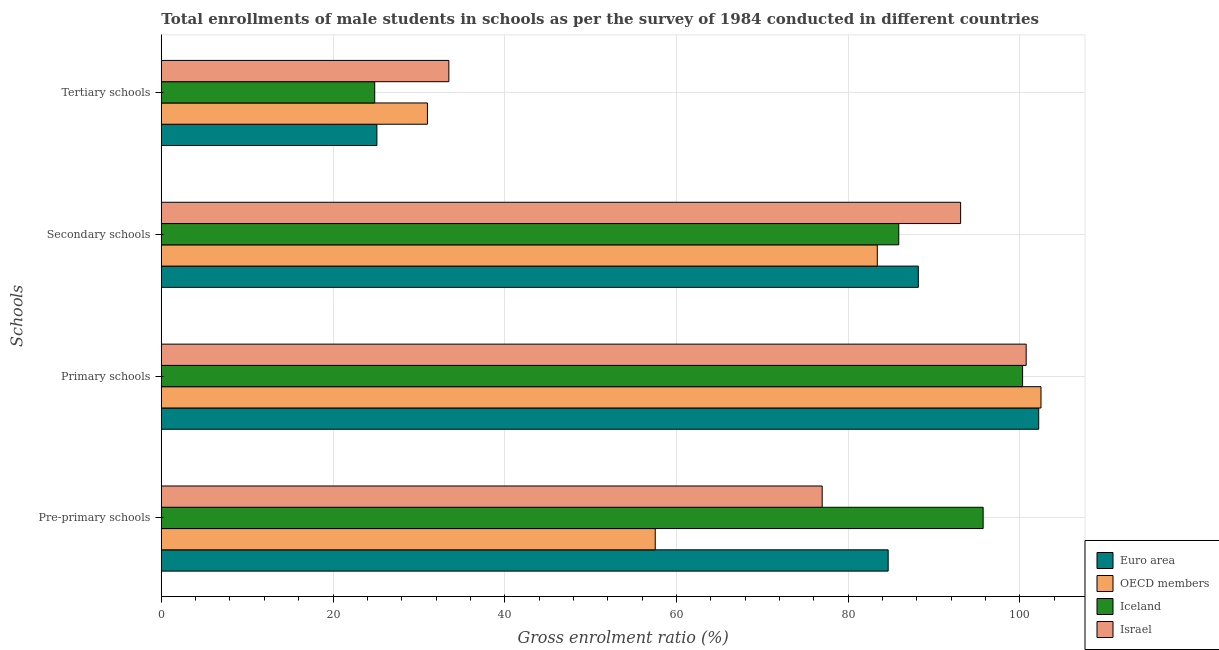How many bars are there on the 2nd tick from the top?
Provide a succinct answer. 4. How many bars are there on the 2nd tick from the bottom?
Ensure brevity in your answer.  4. What is the label of the 2nd group of bars from the top?
Give a very brief answer. Secondary schools. What is the gross enrolment ratio(male) in tertiary schools in Israel?
Ensure brevity in your answer.  33.5. Across all countries, what is the maximum gross enrolment ratio(male) in primary schools?
Your response must be concise. 102.48. Across all countries, what is the minimum gross enrolment ratio(male) in tertiary schools?
Offer a terse response. 24.86. In which country was the gross enrolment ratio(male) in primary schools maximum?
Provide a succinct answer. OECD members. In which country was the gross enrolment ratio(male) in pre-primary schools minimum?
Your answer should be very brief. OECD members. What is the total gross enrolment ratio(male) in tertiary schools in the graph?
Ensure brevity in your answer.  114.47. What is the difference between the gross enrolment ratio(male) in tertiary schools in Israel and that in Euro area?
Provide a short and direct response. 8.38. What is the difference between the gross enrolment ratio(male) in tertiary schools in OECD members and the gross enrolment ratio(male) in pre-primary schools in Israel?
Make the answer very short. -45.99. What is the average gross enrolment ratio(male) in pre-primary schools per country?
Give a very brief answer. 78.74. What is the difference between the gross enrolment ratio(male) in pre-primary schools and gross enrolment ratio(male) in tertiary schools in Euro area?
Give a very brief answer. 59.56. What is the ratio of the gross enrolment ratio(male) in secondary schools in Iceland to that in Israel?
Your answer should be compact. 0.92. Is the gross enrolment ratio(male) in tertiary schools in Euro area less than that in Iceland?
Provide a short and direct response. No. Is the difference between the gross enrolment ratio(male) in pre-primary schools in Iceland and Israel greater than the difference between the gross enrolment ratio(male) in tertiary schools in Iceland and Israel?
Your answer should be very brief. Yes. What is the difference between the highest and the second highest gross enrolment ratio(male) in primary schools?
Provide a short and direct response. 0.27. What is the difference between the highest and the lowest gross enrolment ratio(male) in tertiary schools?
Your answer should be very brief. 8.64. In how many countries, is the gross enrolment ratio(male) in tertiary schools greater than the average gross enrolment ratio(male) in tertiary schools taken over all countries?
Make the answer very short. 2. Is the sum of the gross enrolment ratio(male) in pre-primary schools in Israel and OECD members greater than the maximum gross enrolment ratio(male) in secondary schools across all countries?
Provide a short and direct response. Yes. What does the 2nd bar from the top in Primary schools represents?
Your answer should be very brief. Iceland. Is it the case that in every country, the sum of the gross enrolment ratio(male) in pre-primary schools and gross enrolment ratio(male) in primary schools is greater than the gross enrolment ratio(male) in secondary schools?
Your answer should be very brief. Yes. What is the difference between two consecutive major ticks on the X-axis?
Your response must be concise. 20. Are the values on the major ticks of X-axis written in scientific E-notation?
Offer a terse response. No. Does the graph contain any zero values?
Your answer should be compact. No. How many legend labels are there?
Make the answer very short. 4. What is the title of the graph?
Offer a terse response. Total enrollments of male students in schools as per the survey of 1984 conducted in different countries. What is the label or title of the Y-axis?
Offer a very short reply. Schools. What is the Gross enrolment ratio (%) of Euro area in Pre-primary schools?
Give a very brief answer. 84.68. What is the Gross enrolment ratio (%) of OECD members in Pre-primary schools?
Provide a short and direct response. 57.54. What is the Gross enrolment ratio (%) of Iceland in Pre-primary schools?
Ensure brevity in your answer.  95.74. What is the Gross enrolment ratio (%) of Israel in Pre-primary schools?
Offer a very short reply. 76.99. What is the Gross enrolment ratio (%) of Euro area in Primary schools?
Give a very brief answer. 102.21. What is the Gross enrolment ratio (%) of OECD members in Primary schools?
Offer a terse response. 102.48. What is the Gross enrolment ratio (%) of Iceland in Primary schools?
Your answer should be compact. 100.33. What is the Gross enrolment ratio (%) in Israel in Primary schools?
Provide a short and direct response. 100.75. What is the Gross enrolment ratio (%) in Euro area in Secondary schools?
Make the answer very short. 88.19. What is the Gross enrolment ratio (%) in OECD members in Secondary schools?
Provide a succinct answer. 83.41. What is the Gross enrolment ratio (%) of Iceland in Secondary schools?
Your answer should be very brief. 85.91. What is the Gross enrolment ratio (%) in Israel in Secondary schools?
Keep it short and to the point. 93.11. What is the Gross enrolment ratio (%) of Euro area in Tertiary schools?
Offer a terse response. 25.11. What is the Gross enrolment ratio (%) of OECD members in Tertiary schools?
Give a very brief answer. 31. What is the Gross enrolment ratio (%) in Iceland in Tertiary schools?
Keep it short and to the point. 24.86. What is the Gross enrolment ratio (%) in Israel in Tertiary schools?
Make the answer very short. 33.5. Across all Schools, what is the maximum Gross enrolment ratio (%) in Euro area?
Your answer should be compact. 102.21. Across all Schools, what is the maximum Gross enrolment ratio (%) in OECD members?
Your answer should be very brief. 102.48. Across all Schools, what is the maximum Gross enrolment ratio (%) in Iceland?
Make the answer very short. 100.33. Across all Schools, what is the maximum Gross enrolment ratio (%) of Israel?
Keep it short and to the point. 100.75. Across all Schools, what is the minimum Gross enrolment ratio (%) of Euro area?
Provide a succinct answer. 25.11. Across all Schools, what is the minimum Gross enrolment ratio (%) in OECD members?
Offer a very short reply. 31. Across all Schools, what is the minimum Gross enrolment ratio (%) of Iceland?
Your response must be concise. 24.86. Across all Schools, what is the minimum Gross enrolment ratio (%) of Israel?
Ensure brevity in your answer.  33.5. What is the total Gross enrolment ratio (%) of Euro area in the graph?
Give a very brief answer. 300.19. What is the total Gross enrolment ratio (%) of OECD members in the graph?
Offer a very short reply. 274.43. What is the total Gross enrolment ratio (%) in Iceland in the graph?
Your response must be concise. 306.84. What is the total Gross enrolment ratio (%) of Israel in the graph?
Ensure brevity in your answer.  304.35. What is the difference between the Gross enrolment ratio (%) of Euro area in Pre-primary schools and that in Primary schools?
Your response must be concise. -17.54. What is the difference between the Gross enrolment ratio (%) in OECD members in Pre-primary schools and that in Primary schools?
Your answer should be compact. -44.94. What is the difference between the Gross enrolment ratio (%) in Iceland in Pre-primary schools and that in Primary schools?
Keep it short and to the point. -4.6. What is the difference between the Gross enrolment ratio (%) of Israel in Pre-primary schools and that in Primary schools?
Make the answer very short. -23.76. What is the difference between the Gross enrolment ratio (%) of Euro area in Pre-primary schools and that in Secondary schools?
Provide a short and direct response. -3.51. What is the difference between the Gross enrolment ratio (%) of OECD members in Pre-primary schools and that in Secondary schools?
Ensure brevity in your answer.  -25.87. What is the difference between the Gross enrolment ratio (%) in Iceland in Pre-primary schools and that in Secondary schools?
Offer a very short reply. 9.83. What is the difference between the Gross enrolment ratio (%) of Israel in Pre-primary schools and that in Secondary schools?
Offer a terse response. -16.13. What is the difference between the Gross enrolment ratio (%) in Euro area in Pre-primary schools and that in Tertiary schools?
Give a very brief answer. 59.56. What is the difference between the Gross enrolment ratio (%) of OECD members in Pre-primary schools and that in Tertiary schools?
Your answer should be very brief. 26.54. What is the difference between the Gross enrolment ratio (%) of Iceland in Pre-primary schools and that in Tertiary schools?
Provide a short and direct response. 70.88. What is the difference between the Gross enrolment ratio (%) of Israel in Pre-primary schools and that in Tertiary schools?
Make the answer very short. 43.49. What is the difference between the Gross enrolment ratio (%) in Euro area in Primary schools and that in Secondary schools?
Offer a very short reply. 14.03. What is the difference between the Gross enrolment ratio (%) of OECD members in Primary schools and that in Secondary schools?
Make the answer very short. 19.07. What is the difference between the Gross enrolment ratio (%) in Iceland in Primary schools and that in Secondary schools?
Your answer should be compact. 14.43. What is the difference between the Gross enrolment ratio (%) in Israel in Primary schools and that in Secondary schools?
Your answer should be compact. 7.64. What is the difference between the Gross enrolment ratio (%) in Euro area in Primary schools and that in Tertiary schools?
Provide a succinct answer. 77.1. What is the difference between the Gross enrolment ratio (%) in OECD members in Primary schools and that in Tertiary schools?
Give a very brief answer. 71.48. What is the difference between the Gross enrolment ratio (%) of Iceland in Primary schools and that in Tertiary schools?
Your answer should be very brief. 75.48. What is the difference between the Gross enrolment ratio (%) of Israel in Primary schools and that in Tertiary schools?
Keep it short and to the point. 67.25. What is the difference between the Gross enrolment ratio (%) in Euro area in Secondary schools and that in Tertiary schools?
Your answer should be compact. 63.07. What is the difference between the Gross enrolment ratio (%) of OECD members in Secondary schools and that in Tertiary schools?
Make the answer very short. 52.41. What is the difference between the Gross enrolment ratio (%) in Iceland in Secondary schools and that in Tertiary schools?
Provide a succinct answer. 61.05. What is the difference between the Gross enrolment ratio (%) in Israel in Secondary schools and that in Tertiary schools?
Offer a terse response. 59.62. What is the difference between the Gross enrolment ratio (%) in Euro area in Pre-primary schools and the Gross enrolment ratio (%) in OECD members in Primary schools?
Offer a very short reply. -17.8. What is the difference between the Gross enrolment ratio (%) of Euro area in Pre-primary schools and the Gross enrolment ratio (%) of Iceland in Primary schools?
Keep it short and to the point. -15.66. What is the difference between the Gross enrolment ratio (%) of Euro area in Pre-primary schools and the Gross enrolment ratio (%) of Israel in Primary schools?
Offer a very short reply. -16.08. What is the difference between the Gross enrolment ratio (%) of OECD members in Pre-primary schools and the Gross enrolment ratio (%) of Iceland in Primary schools?
Your response must be concise. -42.8. What is the difference between the Gross enrolment ratio (%) of OECD members in Pre-primary schools and the Gross enrolment ratio (%) of Israel in Primary schools?
Make the answer very short. -43.21. What is the difference between the Gross enrolment ratio (%) in Iceland in Pre-primary schools and the Gross enrolment ratio (%) in Israel in Primary schools?
Keep it short and to the point. -5.01. What is the difference between the Gross enrolment ratio (%) in Euro area in Pre-primary schools and the Gross enrolment ratio (%) in OECD members in Secondary schools?
Your answer should be compact. 1.27. What is the difference between the Gross enrolment ratio (%) in Euro area in Pre-primary schools and the Gross enrolment ratio (%) in Iceland in Secondary schools?
Provide a short and direct response. -1.23. What is the difference between the Gross enrolment ratio (%) in Euro area in Pre-primary schools and the Gross enrolment ratio (%) in Israel in Secondary schools?
Give a very brief answer. -8.44. What is the difference between the Gross enrolment ratio (%) in OECD members in Pre-primary schools and the Gross enrolment ratio (%) in Iceland in Secondary schools?
Your answer should be compact. -28.37. What is the difference between the Gross enrolment ratio (%) of OECD members in Pre-primary schools and the Gross enrolment ratio (%) of Israel in Secondary schools?
Provide a succinct answer. -35.58. What is the difference between the Gross enrolment ratio (%) in Iceland in Pre-primary schools and the Gross enrolment ratio (%) in Israel in Secondary schools?
Offer a terse response. 2.62. What is the difference between the Gross enrolment ratio (%) of Euro area in Pre-primary schools and the Gross enrolment ratio (%) of OECD members in Tertiary schools?
Your answer should be very brief. 53.68. What is the difference between the Gross enrolment ratio (%) of Euro area in Pre-primary schools and the Gross enrolment ratio (%) of Iceland in Tertiary schools?
Your answer should be very brief. 59.82. What is the difference between the Gross enrolment ratio (%) of Euro area in Pre-primary schools and the Gross enrolment ratio (%) of Israel in Tertiary schools?
Your response must be concise. 51.18. What is the difference between the Gross enrolment ratio (%) of OECD members in Pre-primary schools and the Gross enrolment ratio (%) of Iceland in Tertiary schools?
Ensure brevity in your answer.  32.68. What is the difference between the Gross enrolment ratio (%) of OECD members in Pre-primary schools and the Gross enrolment ratio (%) of Israel in Tertiary schools?
Provide a short and direct response. 24.04. What is the difference between the Gross enrolment ratio (%) in Iceland in Pre-primary schools and the Gross enrolment ratio (%) in Israel in Tertiary schools?
Provide a short and direct response. 62.24. What is the difference between the Gross enrolment ratio (%) of Euro area in Primary schools and the Gross enrolment ratio (%) of OECD members in Secondary schools?
Keep it short and to the point. 18.8. What is the difference between the Gross enrolment ratio (%) of Euro area in Primary schools and the Gross enrolment ratio (%) of Iceland in Secondary schools?
Your answer should be very brief. 16.3. What is the difference between the Gross enrolment ratio (%) in Euro area in Primary schools and the Gross enrolment ratio (%) in Israel in Secondary schools?
Provide a short and direct response. 9.1. What is the difference between the Gross enrolment ratio (%) of OECD members in Primary schools and the Gross enrolment ratio (%) of Iceland in Secondary schools?
Offer a very short reply. 16.57. What is the difference between the Gross enrolment ratio (%) in OECD members in Primary schools and the Gross enrolment ratio (%) in Israel in Secondary schools?
Provide a succinct answer. 9.36. What is the difference between the Gross enrolment ratio (%) in Iceland in Primary schools and the Gross enrolment ratio (%) in Israel in Secondary schools?
Offer a terse response. 7.22. What is the difference between the Gross enrolment ratio (%) in Euro area in Primary schools and the Gross enrolment ratio (%) in OECD members in Tertiary schools?
Offer a very short reply. 71.21. What is the difference between the Gross enrolment ratio (%) of Euro area in Primary schools and the Gross enrolment ratio (%) of Iceland in Tertiary schools?
Provide a short and direct response. 77.35. What is the difference between the Gross enrolment ratio (%) in Euro area in Primary schools and the Gross enrolment ratio (%) in Israel in Tertiary schools?
Make the answer very short. 68.72. What is the difference between the Gross enrolment ratio (%) in OECD members in Primary schools and the Gross enrolment ratio (%) in Iceland in Tertiary schools?
Give a very brief answer. 77.62. What is the difference between the Gross enrolment ratio (%) of OECD members in Primary schools and the Gross enrolment ratio (%) of Israel in Tertiary schools?
Your response must be concise. 68.98. What is the difference between the Gross enrolment ratio (%) in Iceland in Primary schools and the Gross enrolment ratio (%) in Israel in Tertiary schools?
Make the answer very short. 66.84. What is the difference between the Gross enrolment ratio (%) in Euro area in Secondary schools and the Gross enrolment ratio (%) in OECD members in Tertiary schools?
Your answer should be very brief. 57.19. What is the difference between the Gross enrolment ratio (%) in Euro area in Secondary schools and the Gross enrolment ratio (%) in Iceland in Tertiary schools?
Offer a very short reply. 63.33. What is the difference between the Gross enrolment ratio (%) of Euro area in Secondary schools and the Gross enrolment ratio (%) of Israel in Tertiary schools?
Keep it short and to the point. 54.69. What is the difference between the Gross enrolment ratio (%) of OECD members in Secondary schools and the Gross enrolment ratio (%) of Iceland in Tertiary schools?
Your answer should be compact. 58.55. What is the difference between the Gross enrolment ratio (%) in OECD members in Secondary schools and the Gross enrolment ratio (%) in Israel in Tertiary schools?
Your answer should be very brief. 49.91. What is the difference between the Gross enrolment ratio (%) in Iceland in Secondary schools and the Gross enrolment ratio (%) in Israel in Tertiary schools?
Provide a succinct answer. 52.41. What is the average Gross enrolment ratio (%) of Euro area per Schools?
Keep it short and to the point. 75.05. What is the average Gross enrolment ratio (%) in OECD members per Schools?
Offer a terse response. 68.61. What is the average Gross enrolment ratio (%) in Iceland per Schools?
Provide a short and direct response. 76.71. What is the average Gross enrolment ratio (%) in Israel per Schools?
Keep it short and to the point. 76.09. What is the difference between the Gross enrolment ratio (%) of Euro area and Gross enrolment ratio (%) of OECD members in Pre-primary schools?
Make the answer very short. 27.14. What is the difference between the Gross enrolment ratio (%) in Euro area and Gross enrolment ratio (%) in Iceland in Pre-primary schools?
Ensure brevity in your answer.  -11.06. What is the difference between the Gross enrolment ratio (%) in Euro area and Gross enrolment ratio (%) in Israel in Pre-primary schools?
Provide a short and direct response. 7.69. What is the difference between the Gross enrolment ratio (%) in OECD members and Gross enrolment ratio (%) in Iceland in Pre-primary schools?
Offer a very short reply. -38.2. What is the difference between the Gross enrolment ratio (%) in OECD members and Gross enrolment ratio (%) in Israel in Pre-primary schools?
Your answer should be compact. -19.45. What is the difference between the Gross enrolment ratio (%) in Iceland and Gross enrolment ratio (%) in Israel in Pre-primary schools?
Provide a short and direct response. 18.75. What is the difference between the Gross enrolment ratio (%) of Euro area and Gross enrolment ratio (%) of OECD members in Primary schools?
Your response must be concise. -0.27. What is the difference between the Gross enrolment ratio (%) of Euro area and Gross enrolment ratio (%) of Iceland in Primary schools?
Provide a short and direct response. 1.88. What is the difference between the Gross enrolment ratio (%) of Euro area and Gross enrolment ratio (%) of Israel in Primary schools?
Give a very brief answer. 1.46. What is the difference between the Gross enrolment ratio (%) in OECD members and Gross enrolment ratio (%) in Iceland in Primary schools?
Provide a short and direct response. 2.14. What is the difference between the Gross enrolment ratio (%) in OECD members and Gross enrolment ratio (%) in Israel in Primary schools?
Provide a short and direct response. 1.73. What is the difference between the Gross enrolment ratio (%) of Iceland and Gross enrolment ratio (%) of Israel in Primary schools?
Your response must be concise. -0.42. What is the difference between the Gross enrolment ratio (%) in Euro area and Gross enrolment ratio (%) in OECD members in Secondary schools?
Offer a terse response. 4.78. What is the difference between the Gross enrolment ratio (%) of Euro area and Gross enrolment ratio (%) of Iceland in Secondary schools?
Provide a short and direct response. 2.28. What is the difference between the Gross enrolment ratio (%) in Euro area and Gross enrolment ratio (%) in Israel in Secondary schools?
Provide a succinct answer. -4.93. What is the difference between the Gross enrolment ratio (%) in OECD members and Gross enrolment ratio (%) in Iceland in Secondary schools?
Your response must be concise. -2.5. What is the difference between the Gross enrolment ratio (%) of OECD members and Gross enrolment ratio (%) of Israel in Secondary schools?
Your response must be concise. -9.71. What is the difference between the Gross enrolment ratio (%) of Iceland and Gross enrolment ratio (%) of Israel in Secondary schools?
Your answer should be compact. -7.21. What is the difference between the Gross enrolment ratio (%) in Euro area and Gross enrolment ratio (%) in OECD members in Tertiary schools?
Your response must be concise. -5.89. What is the difference between the Gross enrolment ratio (%) of Euro area and Gross enrolment ratio (%) of Iceland in Tertiary schools?
Your answer should be compact. 0.25. What is the difference between the Gross enrolment ratio (%) in Euro area and Gross enrolment ratio (%) in Israel in Tertiary schools?
Your answer should be very brief. -8.38. What is the difference between the Gross enrolment ratio (%) in OECD members and Gross enrolment ratio (%) in Iceland in Tertiary schools?
Keep it short and to the point. 6.14. What is the difference between the Gross enrolment ratio (%) in OECD members and Gross enrolment ratio (%) in Israel in Tertiary schools?
Make the answer very short. -2.5. What is the difference between the Gross enrolment ratio (%) in Iceland and Gross enrolment ratio (%) in Israel in Tertiary schools?
Offer a very short reply. -8.64. What is the ratio of the Gross enrolment ratio (%) in Euro area in Pre-primary schools to that in Primary schools?
Provide a succinct answer. 0.83. What is the ratio of the Gross enrolment ratio (%) in OECD members in Pre-primary schools to that in Primary schools?
Make the answer very short. 0.56. What is the ratio of the Gross enrolment ratio (%) in Iceland in Pre-primary schools to that in Primary schools?
Your response must be concise. 0.95. What is the ratio of the Gross enrolment ratio (%) of Israel in Pre-primary schools to that in Primary schools?
Make the answer very short. 0.76. What is the ratio of the Gross enrolment ratio (%) in Euro area in Pre-primary schools to that in Secondary schools?
Your response must be concise. 0.96. What is the ratio of the Gross enrolment ratio (%) in OECD members in Pre-primary schools to that in Secondary schools?
Keep it short and to the point. 0.69. What is the ratio of the Gross enrolment ratio (%) of Iceland in Pre-primary schools to that in Secondary schools?
Your response must be concise. 1.11. What is the ratio of the Gross enrolment ratio (%) in Israel in Pre-primary schools to that in Secondary schools?
Your answer should be compact. 0.83. What is the ratio of the Gross enrolment ratio (%) of Euro area in Pre-primary schools to that in Tertiary schools?
Provide a short and direct response. 3.37. What is the ratio of the Gross enrolment ratio (%) of OECD members in Pre-primary schools to that in Tertiary schools?
Offer a terse response. 1.86. What is the ratio of the Gross enrolment ratio (%) in Iceland in Pre-primary schools to that in Tertiary schools?
Keep it short and to the point. 3.85. What is the ratio of the Gross enrolment ratio (%) of Israel in Pre-primary schools to that in Tertiary schools?
Your answer should be very brief. 2.3. What is the ratio of the Gross enrolment ratio (%) of Euro area in Primary schools to that in Secondary schools?
Your answer should be compact. 1.16. What is the ratio of the Gross enrolment ratio (%) in OECD members in Primary schools to that in Secondary schools?
Give a very brief answer. 1.23. What is the ratio of the Gross enrolment ratio (%) in Iceland in Primary schools to that in Secondary schools?
Your response must be concise. 1.17. What is the ratio of the Gross enrolment ratio (%) in Israel in Primary schools to that in Secondary schools?
Offer a very short reply. 1.08. What is the ratio of the Gross enrolment ratio (%) of Euro area in Primary schools to that in Tertiary schools?
Provide a succinct answer. 4.07. What is the ratio of the Gross enrolment ratio (%) of OECD members in Primary schools to that in Tertiary schools?
Provide a short and direct response. 3.31. What is the ratio of the Gross enrolment ratio (%) in Iceland in Primary schools to that in Tertiary schools?
Ensure brevity in your answer.  4.04. What is the ratio of the Gross enrolment ratio (%) in Israel in Primary schools to that in Tertiary schools?
Your answer should be very brief. 3.01. What is the ratio of the Gross enrolment ratio (%) in Euro area in Secondary schools to that in Tertiary schools?
Give a very brief answer. 3.51. What is the ratio of the Gross enrolment ratio (%) of OECD members in Secondary schools to that in Tertiary schools?
Offer a terse response. 2.69. What is the ratio of the Gross enrolment ratio (%) in Iceland in Secondary schools to that in Tertiary schools?
Give a very brief answer. 3.46. What is the ratio of the Gross enrolment ratio (%) in Israel in Secondary schools to that in Tertiary schools?
Keep it short and to the point. 2.78. What is the difference between the highest and the second highest Gross enrolment ratio (%) of Euro area?
Ensure brevity in your answer.  14.03. What is the difference between the highest and the second highest Gross enrolment ratio (%) of OECD members?
Make the answer very short. 19.07. What is the difference between the highest and the second highest Gross enrolment ratio (%) of Iceland?
Offer a very short reply. 4.6. What is the difference between the highest and the second highest Gross enrolment ratio (%) in Israel?
Your answer should be very brief. 7.64. What is the difference between the highest and the lowest Gross enrolment ratio (%) of Euro area?
Give a very brief answer. 77.1. What is the difference between the highest and the lowest Gross enrolment ratio (%) of OECD members?
Keep it short and to the point. 71.48. What is the difference between the highest and the lowest Gross enrolment ratio (%) in Iceland?
Your answer should be compact. 75.48. What is the difference between the highest and the lowest Gross enrolment ratio (%) of Israel?
Provide a succinct answer. 67.25. 